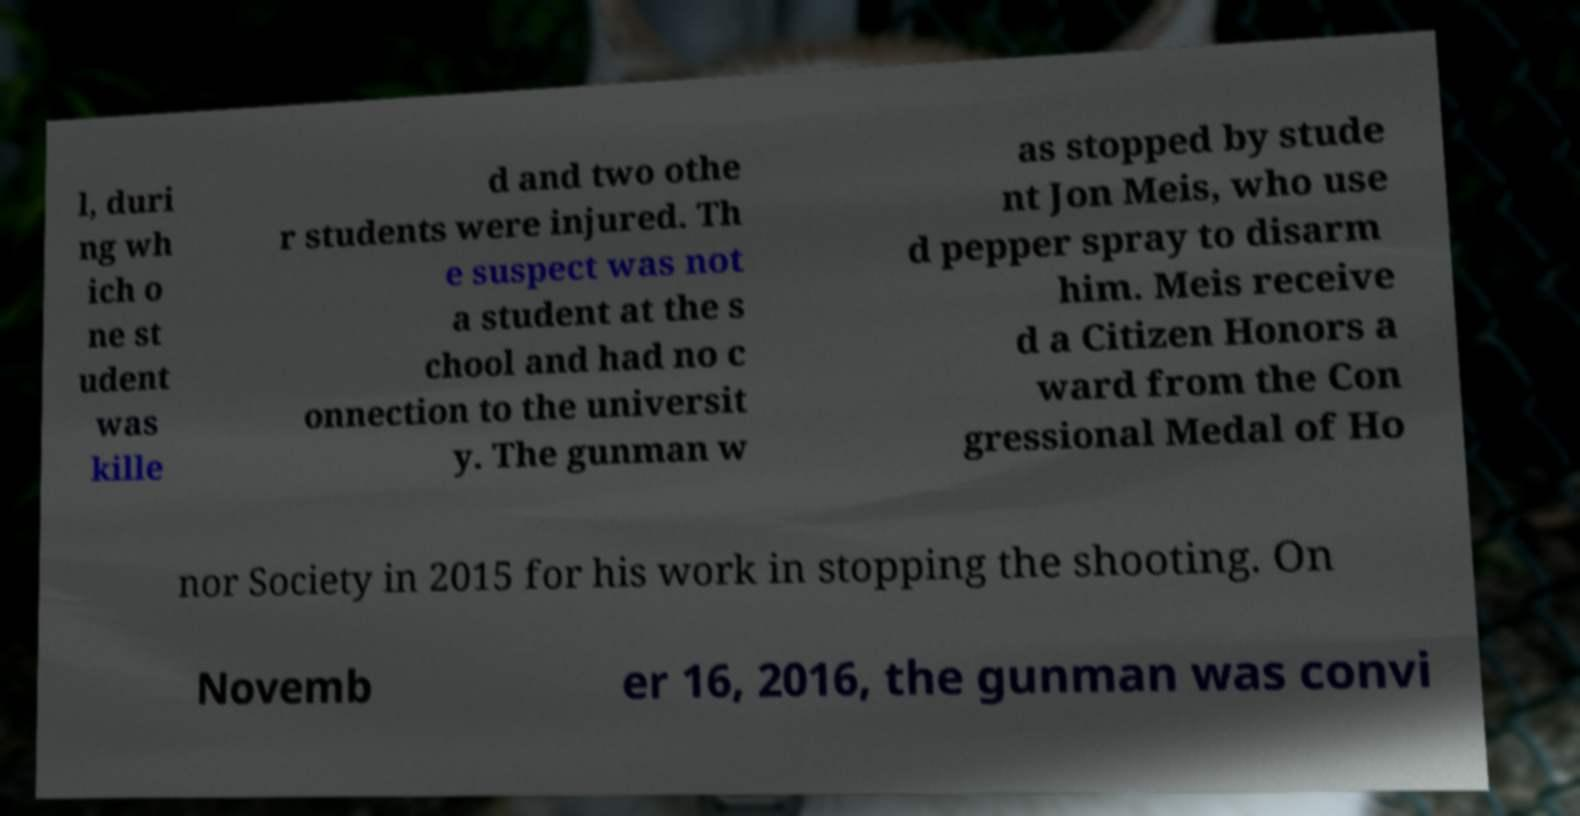For documentation purposes, I need the text within this image transcribed. Could you provide that? l, duri ng wh ich o ne st udent was kille d and two othe r students were injured. Th e suspect was not a student at the s chool and had no c onnection to the universit y. The gunman w as stopped by stude nt Jon Meis, who use d pepper spray to disarm him. Meis receive d a Citizen Honors a ward from the Con gressional Medal of Ho nor Society in 2015 for his work in stopping the shooting. On Novemb er 16, 2016, the gunman was convi 